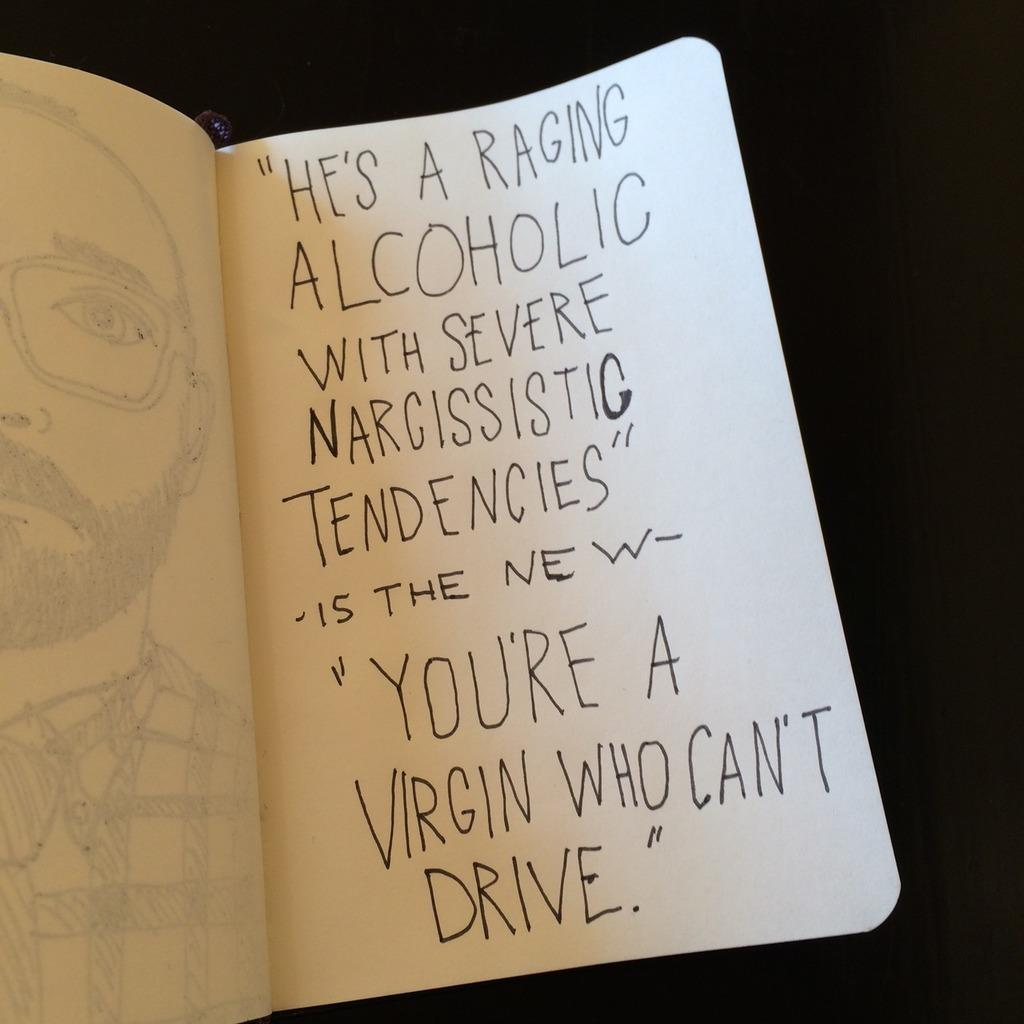<image>
Describe the image concisely. A hand written message which ends with the words 'a virgin who can't drive' 